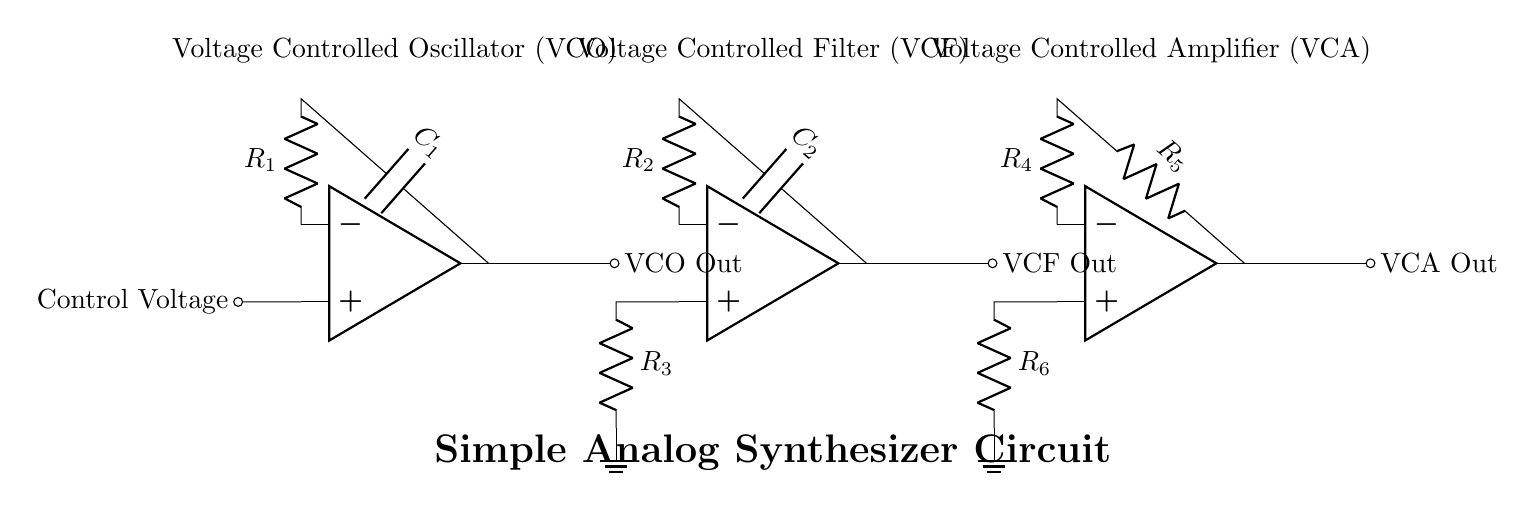What are the components used in the circuit? The circuit includes three operational amplifiers, resistors, and capacitors, specifically labeled as R1, R2, R3, R4, R5, R6, C1, and C2.
Answer: operational amplifiers, resistors, capacitors What is the output of the Voltage Controlled Oscillator (VCO)? According to the diagram, the output of the VCO is labeled as "VCO Out," which indicates the generated audio or modulation signal.
Answer: VCO Out How many resistors are utilized in the entire circuit? There are six resistors present in the diagram, which are labeled as R1 through R6.
Answer: six What role does the capacitor C1 serve in the VCO? The capacitor C1, connected to the op amp in the VCO section, serves to filter the signal by affecting the frequency response; it is vital for determining the oscillation frequency in conjunction with R1.
Answer: filters the signal, determines frequency What would happen if R4 in the Voltage Controlled Amplifier (VCA) were removed? Removing R4 would disconnect the feedback loop in the VCA, likely resulting in loss of gain control, as the op amp would not properly amplify the input signal without feedback.
Answer: loss of gain control Where is the control voltage applied in the circuit? The control voltage is applied at the inverting input of the op amp in the VCO section, where it influences the output frequency of the oscillator directly.
Answer: VCO section input What is the function of the Voltage Controlled Filter (VCF)? The VCF processes the audio signal by selectively allowing certain frequencies to pass while attenuating others, based on the control voltage applied.
Answer: selectively allows frequencies to pass 